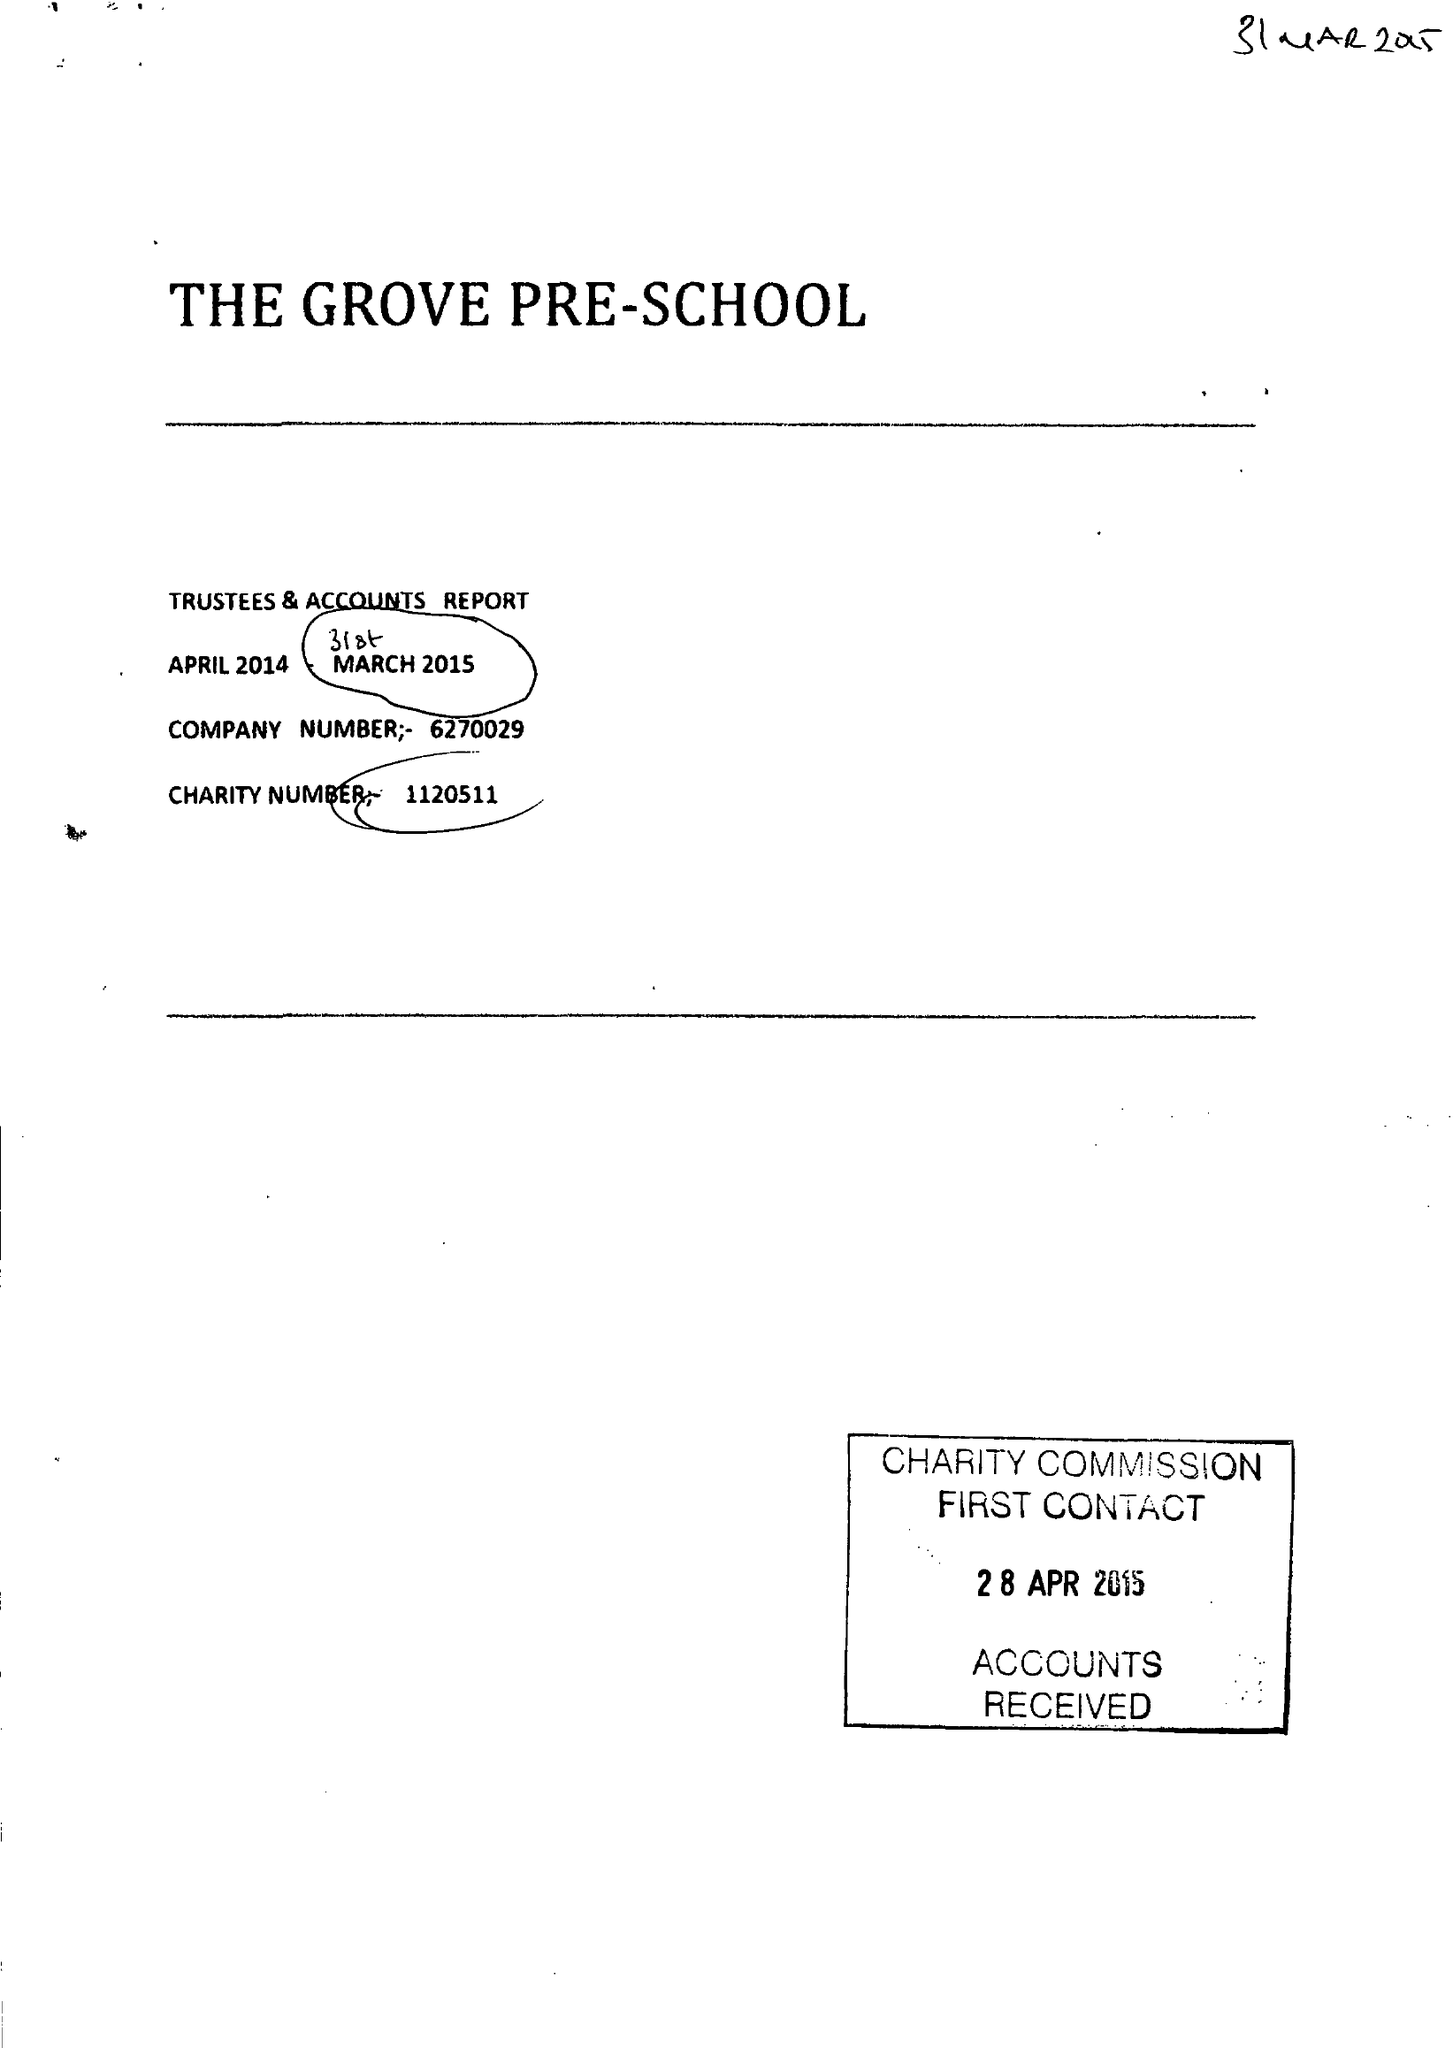What is the value for the charity_name?
Answer the question using a single word or phrase. The Grove Pre-School 